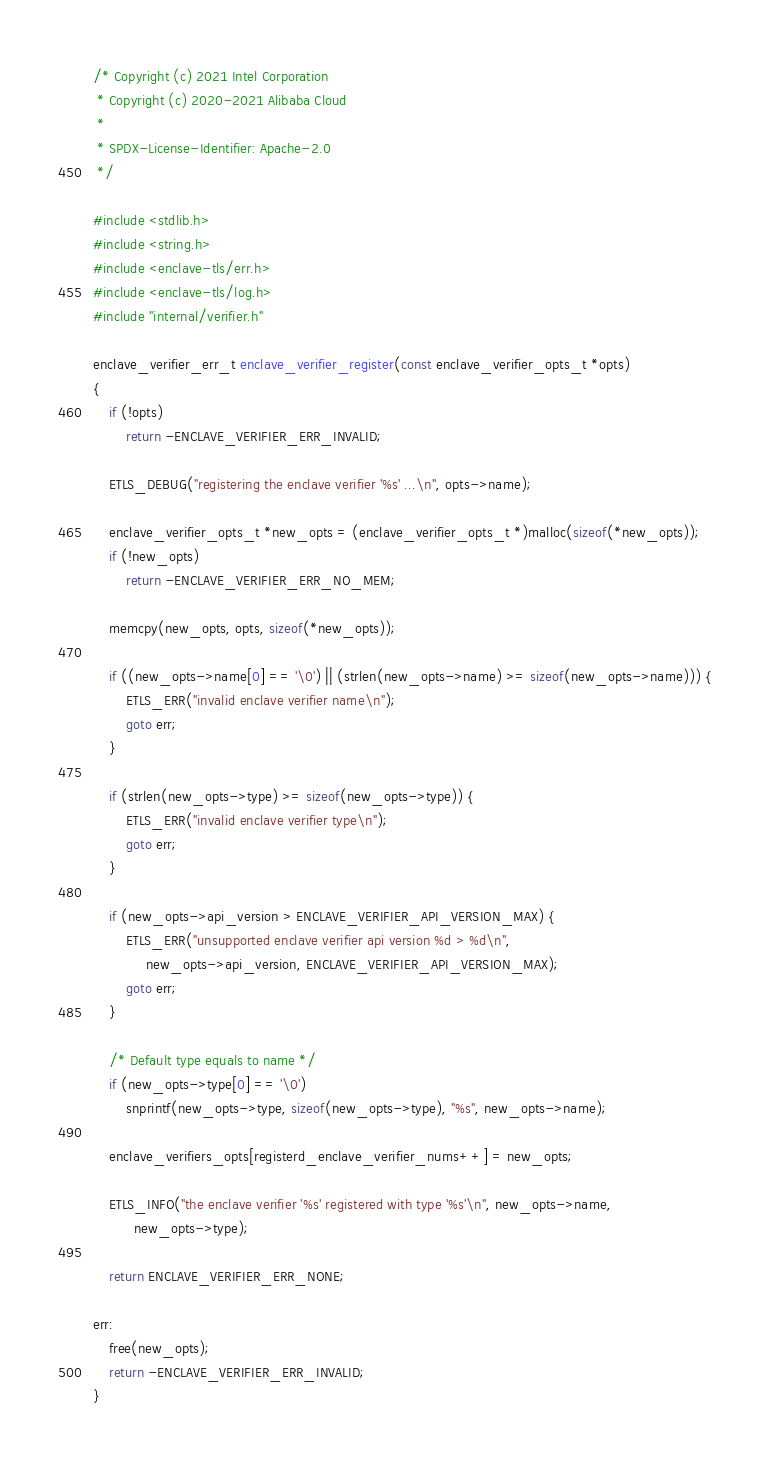<code> <loc_0><loc_0><loc_500><loc_500><_C_>/* Copyright (c) 2021 Intel Corporation
 * Copyright (c) 2020-2021 Alibaba Cloud
 *
 * SPDX-License-Identifier: Apache-2.0
 */

#include <stdlib.h>
#include <string.h>
#include <enclave-tls/err.h>
#include <enclave-tls/log.h>
#include "internal/verifier.h"

enclave_verifier_err_t enclave_verifier_register(const enclave_verifier_opts_t *opts)
{
	if (!opts)
		return -ENCLAVE_VERIFIER_ERR_INVALID;

	ETLS_DEBUG("registering the enclave verifier '%s' ...\n", opts->name);

	enclave_verifier_opts_t *new_opts = (enclave_verifier_opts_t *)malloc(sizeof(*new_opts));
	if (!new_opts)
		return -ENCLAVE_VERIFIER_ERR_NO_MEM;

	memcpy(new_opts, opts, sizeof(*new_opts));

	if ((new_opts->name[0] == '\0') || (strlen(new_opts->name) >= sizeof(new_opts->name))) {
		ETLS_ERR("invalid enclave verifier name\n");
		goto err;
	}

	if (strlen(new_opts->type) >= sizeof(new_opts->type)) {
		ETLS_ERR("invalid enclave verifier type\n");
		goto err;
	}

	if (new_opts->api_version > ENCLAVE_VERIFIER_API_VERSION_MAX) {
		ETLS_ERR("unsupported enclave verifier api version %d > %d\n",
			 new_opts->api_version, ENCLAVE_VERIFIER_API_VERSION_MAX);
		goto err;
	}

	/* Default type equals to name */
	if (new_opts->type[0] == '\0')
		snprintf(new_opts->type, sizeof(new_opts->type), "%s", new_opts->name);

	enclave_verifiers_opts[registerd_enclave_verifier_nums++] = new_opts;

	ETLS_INFO("the enclave verifier '%s' registered with type '%s'\n", new_opts->name,
		  new_opts->type);

	return ENCLAVE_VERIFIER_ERR_NONE;

err:
	free(new_opts);
	return -ENCLAVE_VERIFIER_ERR_INVALID;
}
</code> 